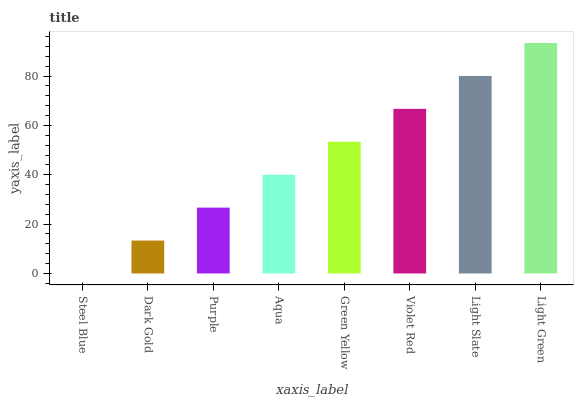Is Steel Blue the minimum?
Answer yes or no. Yes. Is Light Green the maximum?
Answer yes or no. Yes. Is Dark Gold the minimum?
Answer yes or no. No. Is Dark Gold the maximum?
Answer yes or no. No. Is Dark Gold greater than Steel Blue?
Answer yes or no. Yes. Is Steel Blue less than Dark Gold?
Answer yes or no. Yes. Is Steel Blue greater than Dark Gold?
Answer yes or no. No. Is Dark Gold less than Steel Blue?
Answer yes or no. No. Is Green Yellow the high median?
Answer yes or no. Yes. Is Aqua the low median?
Answer yes or no. Yes. Is Violet Red the high median?
Answer yes or no. No. Is Steel Blue the low median?
Answer yes or no. No. 